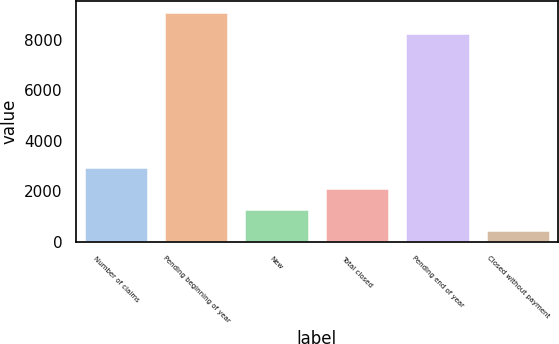Convert chart to OTSL. <chart><loc_0><loc_0><loc_500><loc_500><bar_chart><fcel>Number of claims<fcel>Pending beginning of year<fcel>New<fcel>Total closed<fcel>Pending end of year<fcel>Closed without payment<nl><fcel>2962.3<fcel>9083.1<fcel>1300.1<fcel>2131.2<fcel>8252<fcel>469<nl></chart> 